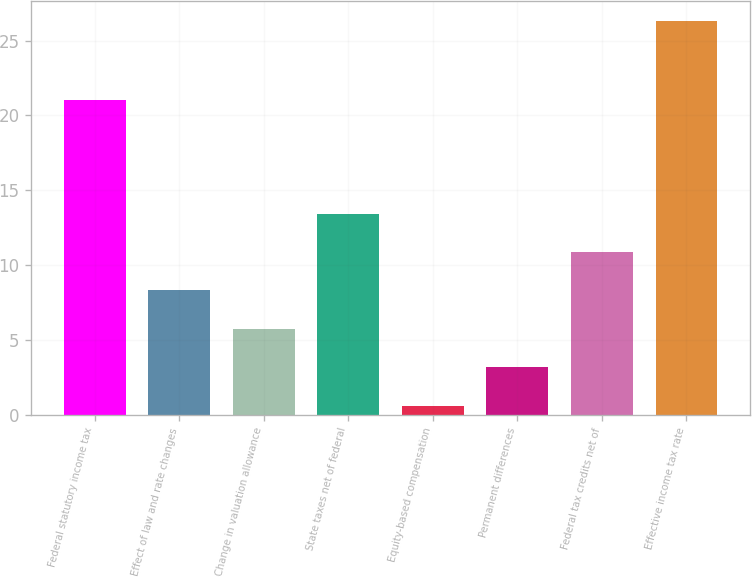Convert chart to OTSL. <chart><loc_0><loc_0><loc_500><loc_500><bar_chart><fcel>Federal statutory income tax<fcel>Effect of law and rate changes<fcel>Change in valuation allowance<fcel>State taxes net of federal<fcel>Equity-based compensation<fcel>Permanent differences<fcel>Federal tax credits net of<fcel>Effective income tax rate<nl><fcel>21<fcel>8.31<fcel>5.74<fcel>13.45<fcel>0.6<fcel>3.17<fcel>10.88<fcel>26.3<nl></chart> 